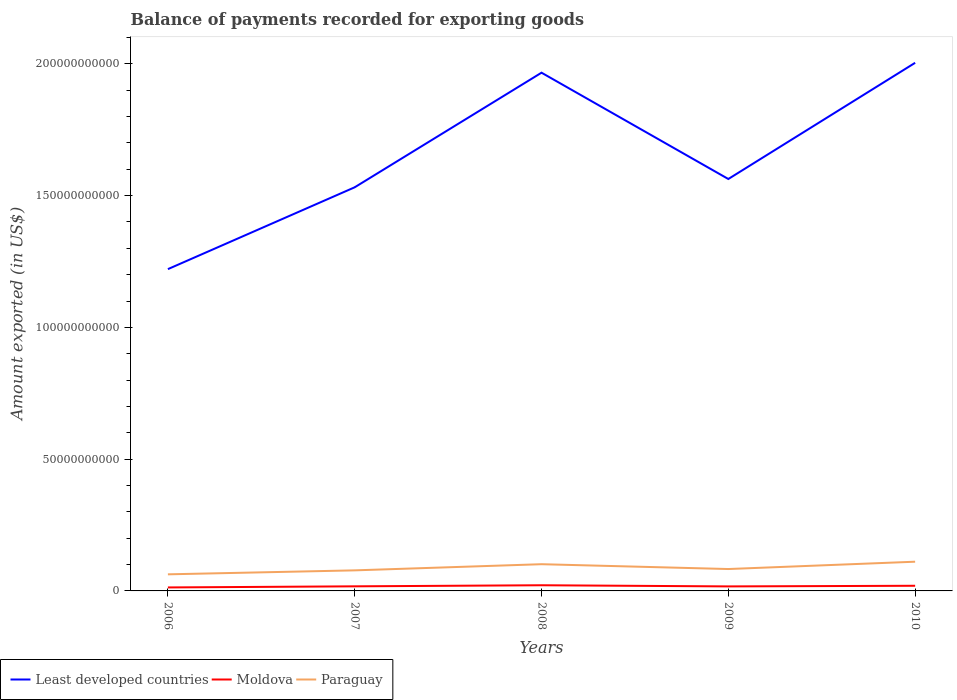Across all years, what is the maximum amount exported in Least developed countries?
Offer a terse response. 1.22e+11. What is the total amount exported in Least developed countries in the graph?
Your answer should be compact. -3.75e+09. What is the difference between the highest and the second highest amount exported in Moldova?
Give a very brief answer. 8.28e+08. What is the difference between the highest and the lowest amount exported in Least developed countries?
Ensure brevity in your answer.  2. How many lines are there?
Your answer should be compact. 3. Are the values on the major ticks of Y-axis written in scientific E-notation?
Offer a terse response. No. Does the graph contain any zero values?
Your answer should be very brief. No. Where does the legend appear in the graph?
Keep it short and to the point. Bottom left. How are the legend labels stacked?
Make the answer very short. Horizontal. What is the title of the graph?
Give a very brief answer. Balance of payments recorded for exporting goods. What is the label or title of the X-axis?
Offer a very short reply. Years. What is the label or title of the Y-axis?
Provide a succinct answer. Amount exported (in US$). What is the Amount exported (in US$) in Least developed countries in 2006?
Your answer should be very brief. 1.22e+11. What is the Amount exported (in US$) of Moldova in 2006?
Make the answer very short. 1.32e+09. What is the Amount exported (in US$) of Paraguay in 2006?
Provide a short and direct response. 6.30e+09. What is the Amount exported (in US$) of Least developed countries in 2007?
Provide a short and direct response. 1.53e+11. What is the Amount exported (in US$) in Moldova in 2007?
Your answer should be compact. 1.75e+09. What is the Amount exported (in US$) of Paraguay in 2007?
Offer a very short reply. 7.80e+09. What is the Amount exported (in US$) in Least developed countries in 2008?
Provide a succinct answer. 1.97e+11. What is the Amount exported (in US$) of Moldova in 2008?
Provide a succinct answer. 2.15e+09. What is the Amount exported (in US$) in Paraguay in 2008?
Make the answer very short. 1.01e+1. What is the Amount exported (in US$) in Least developed countries in 2009?
Your answer should be compact. 1.56e+11. What is the Amount exported (in US$) in Moldova in 2009?
Offer a very short reply. 1.72e+09. What is the Amount exported (in US$) in Paraguay in 2009?
Offer a very short reply. 8.31e+09. What is the Amount exported (in US$) of Least developed countries in 2010?
Provide a succinct answer. 2.00e+11. What is the Amount exported (in US$) in Moldova in 2010?
Offer a terse response. 1.96e+09. What is the Amount exported (in US$) in Paraguay in 2010?
Make the answer very short. 1.11e+1. Across all years, what is the maximum Amount exported (in US$) of Least developed countries?
Your answer should be compact. 2.00e+11. Across all years, what is the maximum Amount exported (in US$) of Moldova?
Give a very brief answer. 2.15e+09. Across all years, what is the maximum Amount exported (in US$) of Paraguay?
Offer a terse response. 1.11e+1. Across all years, what is the minimum Amount exported (in US$) in Least developed countries?
Your answer should be very brief. 1.22e+11. Across all years, what is the minimum Amount exported (in US$) in Moldova?
Provide a short and direct response. 1.32e+09. Across all years, what is the minimum Amount exported (in US$) of Paraguay?
Your response must be concise. 6.30e+09. What is the total Amount exported (in US$) in Least developed countries in the graph?
Make the answer very short. 8.29e+11. What is the total Amount exported (in US$) of Moldova in the graph?
Provide a succinct answer. 8.89e+09. What is the total Amount exported (in US$) of Paraguay in the graph?
Your answer should be compact. 4.36e+1. What is the difference between the Amount exported (in US$) of Least developed countries in 2006 and that in 2007?
Your answer should be very brief. -3.11e+1. What is the difference between the Amount exported (in US$) of Moldova in 2006 and that in 2007?
Your response must be concise. -4.23e+08. What is the difference between the Amount exported (in US$) in Paraguay in 2006 and that in 2007?
Make the answer very short. -1.50e+09. What is the difference between the Amount exported (in US$) in Least developed countries in 2006 and that in 2008?
Make the answer very short. -7.45e+1. What is the difference between the Amount exported (in US$) of Moldova in 2006 and that in 2008?
Offer a very short reply. -8.28e+08. What is the difference between the Amount exported (in US$) of Paraguay in 2006 and that in 2008?
Your answer should be compact. -3.84e+09. What is the difference between the Amount exported (in US$) in Least developed countries in 2006 and that in 2009?
Provide a short and direct response. -3.42e+1. What is the difference between the Amount exported (in US$) in Moldova in 2006 and that in 2009?
Your answer should be very brief. -3.94e+08. What is the difference between the Amount exported (in US$) of Paraguay in 2006 and that in 2009?
Your answer should be very brief. -2.01e+09. What is the difference between the Amount exported (in US$) in Least developed countries in 2006 and that in 2010?
Offer a terse response. -7.83e+1. What is the difference between the Amount exported (in US$) of Moldova in 2006 and that in 2010?
Ensure brevity in your answer.  -6.36e+08. What is the difference between the Amount exported (in US$) in Paraguay in 2006 and that in 2010?
Your answer should be compact. -4.79e+09. What is the difference between the Amount exported (in US$) of Least developed countries in 2007 and that in 2008?
Your response must be concise. -4.35e+1. What is the difference between the Amount exported (in US$) of Moldova in 2007 and that in 2008?
Keep it short and to the point. -4.04e+08. What is the difference between the Amount exported (in US$) of Paraguay in 2007 and that in 2008?
Provide a short and direct response. -2.34e+09. What is the difference between the Amount exported (in US$) of Least developed countries in 2007 and that in 2009?
Offer a very short reply. -3.15e+09. What is the difference between the Amount exported (in US$) of Moldova in 2007 and that in 2009?
Make the answer very short. 2.99e+07. What is the difference between the Amount exported (in US$) of Paraguay in 2007 and that in 2009?
Offer a terse response. -5.06e+08. What is the difference between the Amount exported (in US$) of Least developed countries in 2007 and that in 2010?
Offer a terse response. -4.72e+1. What is the difference between the Amount exported (in US$) of Moldova in 2007 and that in 2010?
Keep it short and to the point. -2.13e+08. What is the difference between the Amount exported (in US$) of Paraguay in 2007 and that in 2010?
Offer a very short reply. -3.29e+09. What is the difference between the Amount exported (in US$) in Least developed countries in 2008 and that in 2009?
Ensure brevity in your answer.  4.03e+1. What is the difference between the Amount exported (in US$) of Moldova in 2008 and that in 2009?
Provide a short and direct response. 4.34e+08. What is the difference between the Amount exported (in US$) of Paraguay in 2008 and that in 2009?
Make the answer very short. 1.83e+09. What is the difference between the Amount exported (in US$) of Least developed countries in 2008 and that in 2010?
Offer a terse response. -3.75e+09. What is the difference between the Amount exported (in US$) in Moldova in 2008 and that in 2010?
Provide a short and direct response. 1.92e+08. What is the difference between the Amount exported (in US$) in Paraguay in 2008 and that in 2010?
Your answer should be very brief. -9.51e+08. What is the difference between the Amount exported (in US$) in Least developed countries in 2009 and that in 2010?
Your response must be concise. -4.41e+1. What is the difference between the Amount exported (in US$) of Moldova in 2009 and that in 2010?
Ensure brevity in your answer.  -2.43e+08. What is the difference between the Amount exported (in US$) of Paraguay in 2009 and that in 2010?
Your answer should be very brief. -2.78e+09. What is the difference between the Amount exported (in US$) in Least developed countries in 2006 and the Amount exported (in US$) in Moldova in 2007?
Your answer should be very brief. 1.20e+11. What is the difference between the Amount exported (in US$) in Least developed countries in 2006 and the Amount exported (in US$) in Paraguay in 2007?
Provide a short and direct response. 1.14e+11. What is the difference between the Amount exported (in US$) in Moldova in 2006 and the Amount exported (in US$) in Paraguay in 2007?
Provide a short and direct response. -6.48e+09. What is the difference between the Amount exported (in US$) in Least developed countries in 2006 and the Amount exported (in US$) in Moldova in 2008?
Your response must be concise. 1.20e+11. What is the difference between the Amount exported (in US$) in Least developed countries in 2006 and the Amount exported (in US$) in Paraguay in 2008?
Give a very brief answer. 1.12e+11. What is the difference between the Amount exported (in US$) of Moldova in 2006 and the Amount exported (in US$) of Paraguay in 2008?
Offer a very short reply. -8.82e+09. What is the difference between the Amount exported (in US$) of Least developed countries in 2006 and the Amount exported (in US$) of Moldova in 2009?
Ensure brevity in your answer.  1.20e+11. What is the difference between the Amount exported (in US$) in Least developed countries in 2006 and the Amount exported (in US$) in Paraguay in 2009?
Your response must be concise. 1.14e+11. What is the difference between the Amount exported (in US$) in Moldova in 2006 and the Amount exported (in US$) in Paraguay in 2009?
Ensure brevity in your answer.  -6.99e+09. What is the difference between the Amount exported (in US$) in Least developed countries in 2006 and the Amount exported (in US$) in Moldova in 2010?
Offer a very short reply. 1.20e+11. What is the difference between the Amount exported (in US$) in Least developed countries in 2006 and the Amount exported (in US$) in Paraguay in 2010?
Provide a short and direct response. 1.11e+11. What is the difference between the Amount exported (in US$) in Moldova in 2006 and the Amount exported (in US$) in Paraguay in 2010?
Offer a terse response. -9.77e+09. What is the difference between the Amount exported (in US$) of Least developed countries in 2007 and the Amount exported (in US$) of Moldova in 2008?
Your answer should be compact. 1.51e+11. What is the difference between the Amount exported (in US$) in Least developed countries in 2007 and the Amount exported (in US$) in Paraguay in 2008?
Offer a very short reply. 1.43e+11. What is the difference between the Amount exported (in US$) of Moldova in 2007 and the Amount exported (in US$) of Paraguay in 2008?
Your answer should be compact. -8.39e+09. What is the difference between the Amount exported (in US$) of Least developed countries in 2007 and the Amount exported (in US$) of Moldova in 2009?
Keep it short and to the point. 1.51e+11. What is the difference between the Amount exported (in US$) in Least developed countries in 2007 and the Amount exported (in US$) in Paraguay in 2009?
Provide a short and direct response. 1.45e+11. What is the difference between the Amount exported (in US$) of Moldova in 2007 and the Amount exported (in US$) of Paraguay in 2009?
Provide a short and direct response. -6.56e+09. What is the difference between the Amount exported (in US$) in Least developed countries in 2007 and the Amount exported (in US$) in Moldova in 2010?
Ensure brevity in your answer.  1.51e+11. What is the difference between the Amount exported (in US$) of Least developed countries in 2007 and the Amount exported (in US$) of Paraguay in 2010?
Ensure brevity in your answer.  1.42e+11. What is the difference between the Amount exported (in US$) in Moldova in 2007 and the Amount exported (in US$) in Paraguay in 2010?
Make the answer very short. -9.34e+09. What is the difference between the Amount exported (in US$) in Least developed countries in 2008 and the Amount exported (in US$) in Moldova in 2009?
Ensure brevity in your answer.  1.95e+11. What is the difference between the Amount exported (in US$) in Least developed countries in 2008 and the Amount exported (in US$) in Paraguay in 2009?
Your answer should be very brief. 1.88e+11. What is the difference between the Amount exported (in US$) of Moldova in 2008 and the Amount exported (in US$) of Paraguay in 2009?
Provide a succinct answer. -6.16e+09. What is the difference between the Amount exported (in US$) in Least developed countries in 2008 and the Amount exported (in US$) in Moldova in 2010?
Keep it short and to the point. 1.95e+11. What is the difference between the Amount exported (in US$) of Least developed countries in 2008 and the Amount exported (in US$) of Paraguay in 2010?
Keep it short and to the point. 1.86e+11. What is the difference between the Amount exported (in US$) of Moldova in 2008 and the Amount exported (in US$) of Paraguay in 2010?
Your response must be concise. -8.94e+09. What is the difference between the Amount exported (in US$) in Least developed countries in 2009 and the Amount exported (in US$) in Moldova in 2010?
Make the answer very short. 1.54e+11. What is the difference between the Amount exported (in US$) of Least developed countries in 2009 and the Amount exported (in US$) of Paraguay in 2010?
Offer a terse response. 1.45e+11. What is the difference between the Amount exported (in US$) of Moldova in 2009 and the Amount exported (in US$) of Paraguay in 2010?
Provide a short and direct response. -9.37e+09. What is the average Amount exported (in US$) in Least developed countries per year?
Your response must be concise. 1.66e+11. What is the average Amount exported (in US$) of Moldova per year?
Keep it short and to the point. 1.78e+09. What is the average Amount exported (in US$) of Paraguay per year?
Give a very brief answer. 8.73e+09. In the year 2006, what is the difference between the Amount exported (in US$) in Least developed countries and Amount exported (in US$) in Moldova?
Ensure brevity in your answer.  1.21e+11. In the year 2006, what is the difference between the Amount exported (in US$) of Least developed countries and Amount exported (in US$) of Paraguay?
Your response must be concise. 1.16e+11. In the year 2006, what is the difference between the Amount exported (in US$) of Moldova and Amount exported (in US$) of Paraguay?
Provide a short and direct response. -4.98e+09. In the year 2007, what is the difference between the Amount exported (in US$) in Least developed countries and Amount exported (in US$) in Moldova?
Ensure brevity in your answer.  1.51e+11. In the year 2007, what is the difference between the Amount exported (in US$) of Least developed countries and Amount exported (in US$) of Paraguay?
Provide a succinct answer. 1.45e+11. In the year 2007, what is the difference between the Amount exported (in US$) in Moldova and Amount exported (in US$) in Paraguay?
Make the answer very short. -6.06e+09. In the year 2008, what is the difference between the Amount exported (in US$) in Least developed countries and Amount exported (in US$) in Moldova?
Offer a terse response. 1.95e+11. In the year 2008, what is the difference between the Amount exported (in US$) of Least developed countries and Amount exported (in US$) of Paraguay?
Provide a succinct answer. 1.87e+11. In the year 2008, what is the difference between the Amount exported (in US$) in Moldova and Amount exported (in US$) in Paraguay?
Your response must be concise. -7.99e+09. In the year 2009, what is the difference between the Amount exported (in US$) of Least developed countries and Amount exported (in US$) of Moldova?
Your answer should be compact. 1.55e+11. In the year 2009, what is the difference between the Amount exported (in US$) in Least developed countries and Amount exported (in US$) in Paraguay?
Offer a terse response. 1.48e+11. In the year 2009, what is the difference between the Amount exported (in US$) of Moldova and Amount exported (in US$) of Paraguay?
Ensure brevity in your answer.  -6.59e+09. In the year 2010, what is the difference between the Amount exported (in US$) of Least developed countries and Amount exported (in US$) of Moldova?
Provide a succinct answer. 1.98e+11. In the year 2010, what is the difference between the Amount exported (in US$) in Least developed countries and Amount exported (in US$) in Paraguay?
Your answer should be compact. 1.89e+11. In the year 2010, what is the difference between the Amount exported (in US$) in Moldova and Amount exported (in US$) in Paraguay?
Keep it short and to the point. -9.13e+09. What is the ratio of the Amount exported (in US$) of Least developed countries in 2006 to that in 2007?
Offer a very short reply. 0.8. What is the ratio of the Amount exported (in US$) in Moldova in 2006 to that in 2007?
Keep it short and to the point. 0.76. What is the ratio of the Amount exported (in US$) in Paraguay in 2006 to that in 2007?
Give a very brief answer. 0.81. What is the ratio of the Amount exported (in US$) of Least developed countries in 2006 to that in 2008?
Your response must be concise. 0.62. What is the ratio of the Amount exported (in US$) of Moldova in 2006 to that in 2008?
Your answer should be compact. 0.61. What is the ratio of the Amount exported (in US$) of Paraguay in 2006 to that in 2008?
Offer a terse response. 0.62. What is the ratio of the Amount exported (in US$) in Least developed countries in 2006 to that in 2009?
Your response must be concise. 0.78. What is the ratio of the Amount exported (in US$) of Moldova in 2006 to that in 2009?
Make the answer very short. 0.77. What is the ratio of the Amount exported (in US$) in Paraguay in 2006 to that in 2009?
Keep it short and to the point. 0.76. What is the ratio of the Amount exported (in US$) of Least developed countries in 2006 to that in 2010?
Keep it short and to the point. 0.61. What is the ratio of the Amount exported (in US$) in Moldova in 2006 to that in 2010?
Provide a succinct answer. 0.68. What is the ratio of the Amount exported (in US$) of Paraguay in 2006 to that in 2010?
Offer a terse response. 0.57. What is the ratio of the Amount exported (in US$) in Least developed countries in 2007 to that in 2008?
Make the answer very short. 0.78. What is the ratio of the Amount exported (in US$) in Moldova in 2007 to that in 2008?
Your answer should be very brief. 0.81. What is the ratio of the Amount exported (in US$) in Paraguay in 2007 to that in 2008?
Offer a very short reply. 0.77. What is the ratio of the Amount exported (in US$) of Least developed countries in 2007 to that in 2009?
Give a very brief answer. 0.98. What is the ratio of the Amount exported (in US$) in Moldova in 2007 to that in 2009?
Give a very brief answer. 1.02. What is the ratio of the Amount exported (in US$) of Paraguay in 2007 to that in 2009?
Keep it short and to the point. 0.94. What is the ratio of the Amount exported (in US$) in Least developed countries in 2007 to that in 2010?
Ensure brevity in your answer.  0.76. What is the ratio of the Amount exported (in US$) in Moldova in 2007 to that in 2010?
Make the answer very short. 0.89. What is the ratio of the Amount exported (in US$) of Paraguay in 2007 to that in 2010?
Make the answer very short. 0.7. What is the ratio of the Amount exported (in US$) of Least developed countries in 2008 to that in 2009?
Provide a short and direct response. 1.26. What is the ratio of the Amount exported (in US$) of Moldova in 2008 to that in 2009?
Keep it short and to the point. 1.25. What is the ratio of the Amount exported (in US$) in Paraguay in 2008 to that in 2009?
Offer a very short reply. 1.22. What is the ratio of the Amount exported (in US$) of Least developed countries in 2008 to that in 2010?
Offer a very short reply. 0.98. What is the ratio of the Amount exported (in US$) of Moldova in 2008 to that in 2010?
Your answer should be very brief. 1.1. What is the ratio of the Amount exported (in US$) of Paraguay in 2008 to that in 2010?
Keep it short and to the point. 0.91. What is the ratio of the Amount exported (in US$) in Least developed countries in 2009 to that in 2010?
Your answer should be compact. 0.78. What is the ratio of the Amount exported (in US$) in Moldova in 2009 to that in 2010?
Provide a short and direct response. 0.88. What is the ratio of the Amount exported (in US$) of Paraguay in 2009 to that in 2010?
Your answer should be very brief. 0.75. What is the difference between the highest and the second highest Amount exported (in US$) of Least developed countries?
Offer a very short reply. 3.75e+09. What is the difference between the highest and the second highest Amount exported (in US$) in Moldova?
Your response must be concise. 1.92e+08. What is the difference between the highest and the second highest Amount exported (in US$) in Paraguay?
Your answer should be very brief. 9.51e+08. What is the difference between the highest and the lowest Amount exported (in US$) in Least developed countries?
Offer a terse response. 7.83e+1. What is the difference between the highest and the lowest Amount exported (in US$) of Moldova?
Ensure brevity in your answer.  8.28e+08. What is the difference between the highest and the lowest Amount exported (in US$) of Paraguay?
Provide a succinct answer. 4.79e+09. 